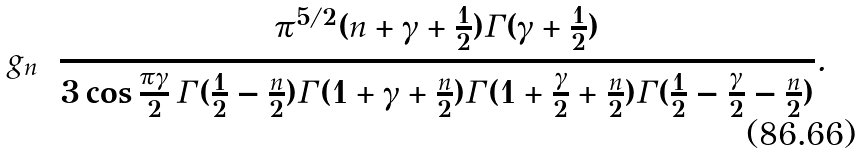Convert formula to latex. <formula><loc_0><loc_0><loc_500><loc_500>g _ { n } = \frac { \pi ^ { 5 / 2 } ( n + \gamma + \frac { 1 } { 2 } ) \Gamma ( \gamma + \frac { 1 } { 2 } ) } { 3 \cos \frac { \pi \gamma } { 2 } \, \Gamma ( \frac { 1 } { 2 } - \frac { n } { 2 } ) \Gamma ( 1 + \gamma + \frac { n } { 2 } ) \Gamma ( 1 + \frac { \gamma } { 2 } + \frac { n } { 2 } ) \Gamma ( \frac { 1 } { 2 } - \frac { \gamma } { 2 } - \frac { n } { 2 } ) } .</formula> 